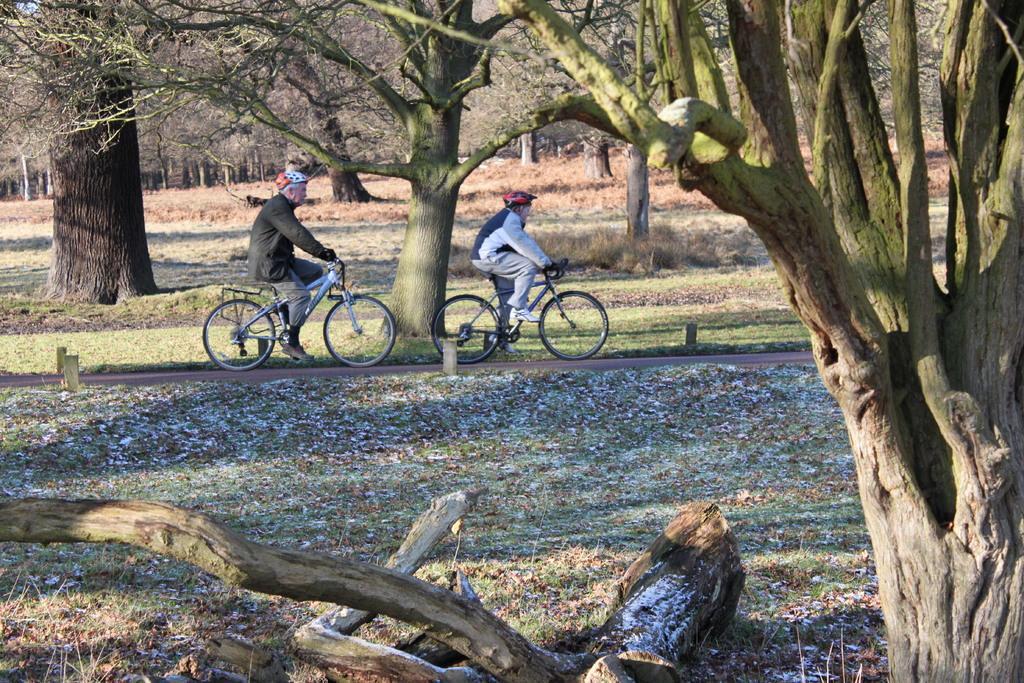Can you describe this image briefly? In the image we can see there are people who are sitting on bicycle and they are standing on the road and behind them there are lot of trees. 